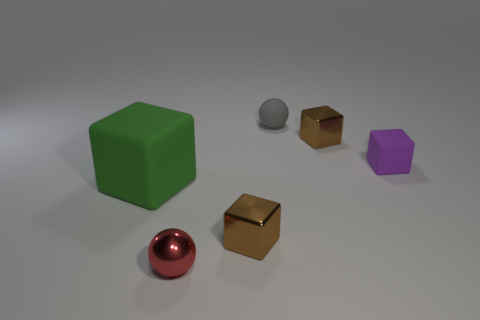What is the size of the other matte thing that is the same shape as the large rubber thing?
Your answer should be compact. Small. Is the shape of the tiny brown thing behind the purple matte block the same as  the large green thing?
Keep it short and to the point. Yes. The matte thing that is in front of the purple matte cube is what color?
Offer a very short reply. Green. What number of other objects are the same size as the gray rubber thing?
Provide a succinct answer. 4. Is there anything else that has the same shape as the large green object?
Ensure brevity in your answer.  Yes. Are there the same number of gray rubber things in front of the large green rubber object and tiny yellow rubber cylinders?
Make the answer very short. Yes. How many brown things have the same material as the tiny red sphere?
Your answer should be very brief. 2. What is the color of the tiny cube that is the same material as the gray thing?
Offer a very short reply. Purple. Is the green object the same shape as the small purple object?
Keep it short and to the point. Yes. Is there a small rubber object that is behind the object that is left of the small ball left of the gray object?
Give a very brief answer. Yes. 